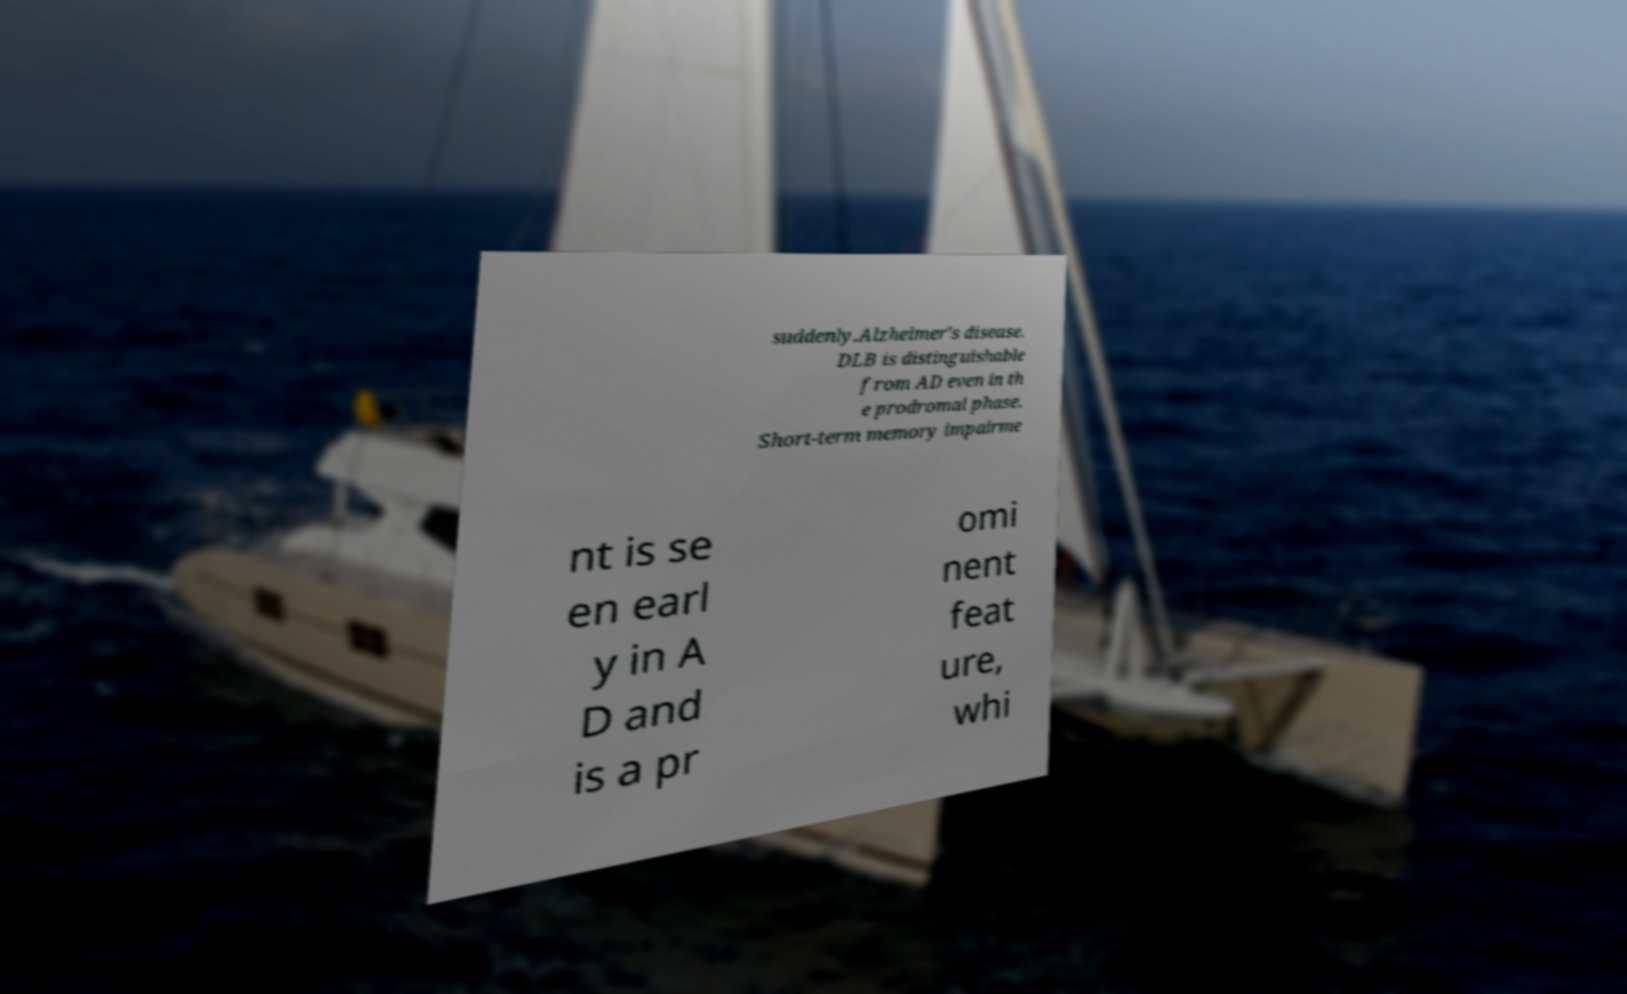For documentation purposes, I need the text within this image transcribed. Could you provide that? suddenly.Alzheimer's disease. DLB is distinguishable from AD even in th e prodromal phase. Short-term memory impairme nt is se en earl y in A D and is a pr omi nent feat ure, whi 